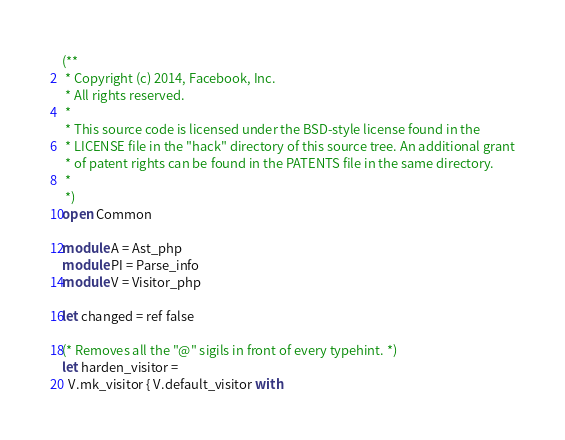Convert code to text. <code><loc_0><loc_0><loc_500><loc_500><_OCaml_>(**
 * Copyright (c) 2014, Facebook, Inc.
 * All rights reserved.
 *
 * This source code is licensed under the BSD-style license found in the
 * LICENSE file in the "hack" directory of this source tree. An additional grant
 * of patent rights can be found in the PATENTS file in the same directory.
 *
 *)
open Common

module A = Ast_php
module PI = Parse_info
module V = Visitor_php

let changed = ref false

(* Removes all the "@" sigils in front of every typehint. *)
let harden_visitor =
  V.mk_visitor { V.default_visitor with</code> 